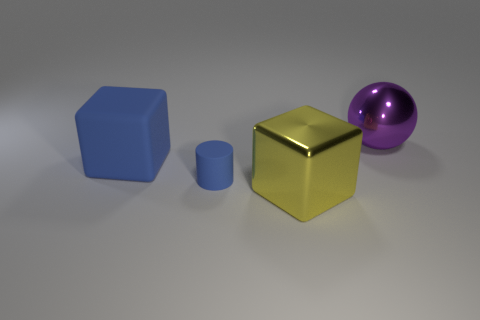How many other objects are the same shape as the large blue object? There is one other object that shares the same shape as the large blue object, which is the small blue cylinder. 